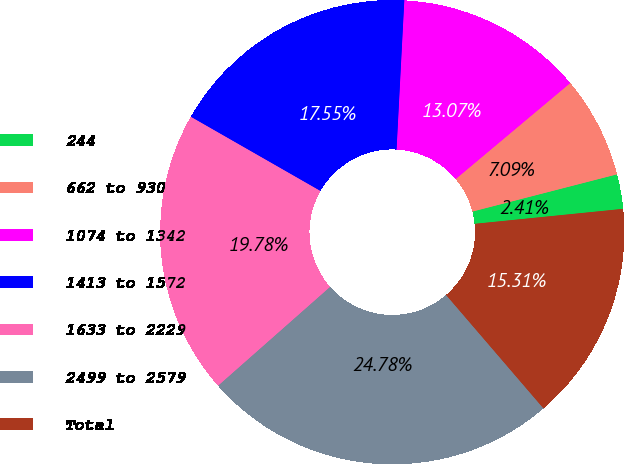Convert chart. <chart><loc_0><loc_0><loc_500><loc_500><pie_chart><fcel>244<fcel>662 to 930<fcel>1074 to 1342<fcel>1413 to 1572<fcel>1633 to 2229<fcel>2499 to 2579<fcel>Total<nl><fcel>2.41%<fcel>7.09%<fcel>13.07%<fcel>17.55%<fcel>19.78%<fcel>24.78%<fcel>15.31%<nl></chart> 